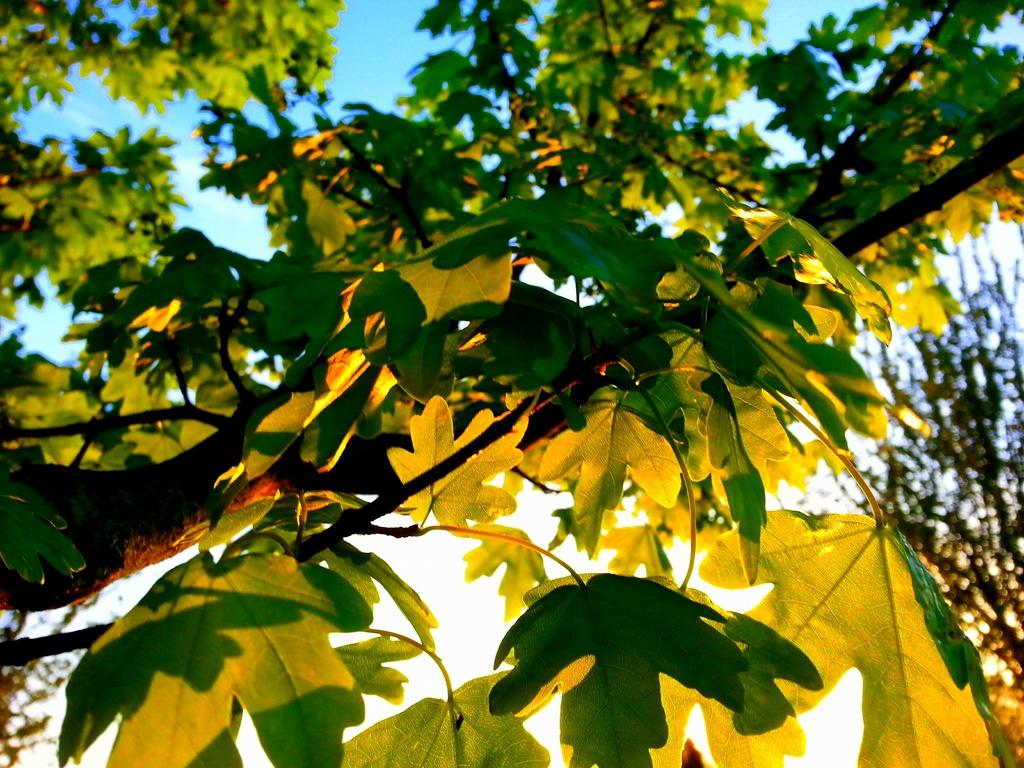What is the main object in the image? There is a tree in the image. What is the color of the tree's leaves? The tree has green leaves. What can be seen in the background of the image? There is a blue sky in the background of the image. What type of shoes is the goat wearing in the image? There is no goat or shoes present in the image; it features a tree with green leaves and a blue sky in the background. 